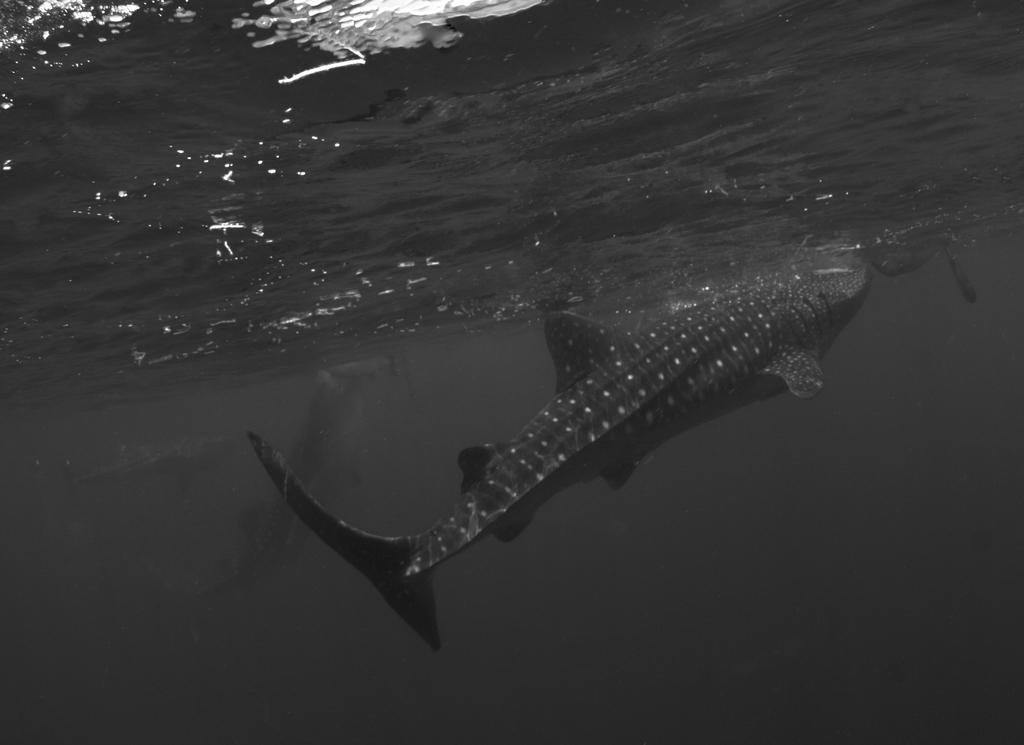What is the color scheme of the image? The image is black and white. What can be seen in the water in the image? There are fishes swimming in the water. Can you describe the movement of one of the fishes in the image? There is a large fish swimming in the upward direction. What type of collar can be seen on the machine in the image? There is no machine or collar present in the image; it features fishes swimming in the water. 